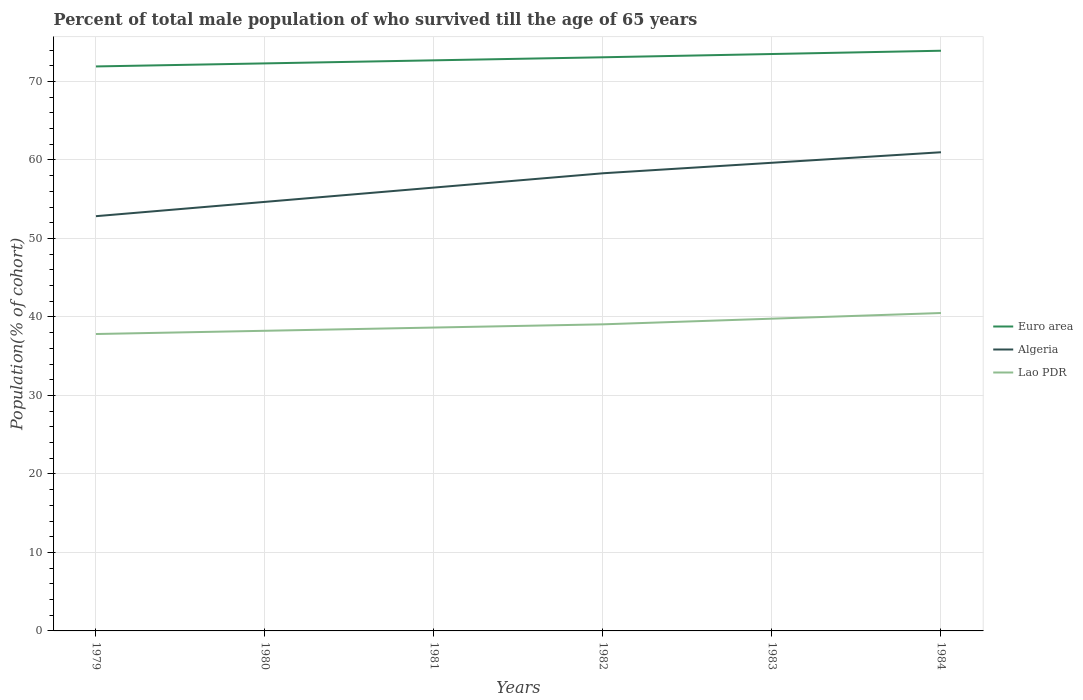Is the number of lines equal to the number of legend labels?
Provide a short and direct response. Yes. Across all years, what is the maximum percentage of total male population who survived till the age of 65 years in Euro area?
Your answer should be compact. 71.92. In which year was the percentage of total male population who survived till the age of 65 years in Euro area maximum?
Make the answer very short. 1979. What is the total percentage of total male population who survived till the age of 65 years in Lao PDR in the graph?
Offer a very short reply. -0.41. What is the difference between the highest and the second highest percentage of total male population who survived till the age of 65 years in Euro area?
Offer a terse response. 2. What is the difference between the highest and the lowest percentage of total male population who survived till the age of 65 years in Euro area?
Give a very brief answer. 3. Is the percentage of total male population who survived till the age of 65 years in Lao PDR strictly greater than the percentage of total male population who survived till the age of 65 years in Euro area over the years?
Your response must be concise. Yes. What is the difference between two consecutive major ticks on the Y-axis?
Ensure brevity in your answer.  10. Are the values on the major ticks of Y-axis written in scientific E-notation?
Make the answer very short. No. Does the graph contain grids?
Ensure brevity in your answer.  Yes. Where does the legend appear in the graph?
Make the answer very short. Center right. How are the legend labels stacked?
Ensure brevity in your answer.  Vertical. What is the title of the graph?
Provide a short and direct response. Percent of total male population of who survived till the age of 65 years. What is the label or title of the Y-axis?
Provide a succinct answer. Population(% of cohort). What is the Population(% of cohort) of Euro area in 1979?
Offer a very short reply. 71.92. What is the Population(% of cohort) in Algeria in 1979?
Make the answer very short. 52.84. What is the Population(% of cohort) in Lao PDR in 1979?
Provide a succinct answer. 37.83. What is the Population(% of cohort) of Euro area in 1980?
Your answer should be very brief. 72.31. What is the Population(% of cohort) of Algeria in 1980?
Offer a very short reply. 54.66. What is the Population(% of cohort) of Lao PDR in 1980?
Your answer should be very brief. 38.24. What is the Population(% of cohort) in Euro area in 1981?
Give a very brief answer. 72.7. What is the Population(% of cohort) of Algeria in 1981?
Provide a succinct answer. 56.49. What is the Population(% of cohort) of Lao PDR in 1981?
Provide a succinct answer. 38.65. What is the Population(% of cohort) in Euro area in 1982?
Provide a succinct answer. 73.09. What is the Population(% of cohort) in Algeria in 1982?
Make the answer very short. 58.31. What is the Population(% of cohort) of Lao PDR in 1982?
Give a very brief answer. 39.06. What is the Population(% of cohort) in Euro area in 1983?
Your answer should be compact. 73.5. What is the Population(% of cohort) in Algeria in 1983?
Offer a terse response. 59.65. What is the Population(% of cohort) of Lao PDR in 1983?
Make the answer very short. 39.78. What is the Population(% of cohort) of Euro area in 1984?
Give a very brief answer. 73.92. What is the Population(% of cohort) in Algeria in 1984?
Your answer should be compact. 60.99. What is the Population(% of cohort) of Lao PDR in 1984?
Keep it short and to the point. 40.5. Across all years, what is the maximum Population(% of cohort) in Euro area?
Your answer should be very brief. 73.92. Across all years, what is the maximum Population(% of cohort) of Algeria?
Provide a succinct answer. 60.99. Across all years, what is the maximum Population(% of cohort) in Lao PDR?
Provide a succinct answer. 40.5. Across all years, what is the minimum Population(% of cohort) in Euro area?
Offer a very short reply. 71.92. Across all years, what is the minimum Population(% of cohort) in Algeria?
Offer a very short reply. 52.84. Across all years, what is the minimum Population(% of cohort) in Lao PDR?
Provide a succinct answer. 37.83. What is the total Population(% of cohort) in Euro area in the graph?
Give a very brief answer. 437.43. What is the total Population(% of cohort) in Algeria in the graph?
Offer a very short reply. 342.93. What is the total Population(% of cohort) of Lao PDR in the graph?
Your answer should be compact. 234.07. What is the difference between the Population(% of cohort) of Euro area in 1979 and that in 1980?
Keep it short and to the point. -0.39. What is the difference between the Population(% of cohort) of Algeria in 1979 and that in 1980?
Keep it short and to the point. -1.82. What is the difference between the Population(% of cohort) of Lao PDR in 1979 and that in 1980?
Your response must be concise. -0.41. What is the difference between the Population(% of cohort) of Euro area in 1979 and that in 1981?
Make the answer very short. -0.78. What is the difference between the Population(% of cohort) of Algeria in 1979 and that in 1981?
Your response must be concise. -3.64. What is the difference between the Population(% of cohort) of Lao PDR in 1979 and that in 1981?
Ensure brevity in your answer.  -0.82. What is the difference between the Population(% of cohort) in Euro area in 1979 and that in 1982?
Ensure brevity in your answer.  -1.17. What is the difference between the Population(% of cohort) in Algeria in 1979 and that in 1982?
Make the answer very short. -5.47. What is the difference between the Population(% of cohort) in Lao PDR in 1979 and that in 1982?
Give a very brief answer. -1.23. What is the difference between the Population(% of cohort) in Euro area in 1979 and that in 1983?
Keep it short and to the point. -1.58. What is the difference between the Population(% of cohort) in Algeria in 1979 and that in 1983?
Keep it short and to the point. -6.81. What is the difference between the Population(% of cohort) of Lao PDR in 1979 and that in 1983?
Keep it short and to the point. -1.95. What is the difference between the Population(% of cohort) in Euro area in 1979 and that in 1984?
Give a very brief answer. -2. What is the difference between the Population(% of cohort) of Algeria in 1979 and that in 1984?
Give a very brief answer. -8.14. What is the difference between the Population(% of cohort) of Lao PDR in 1979 and that in 1984?
Offer a very short reply. -2.68. What is the difference between the Population(% of cohort) in Euro area in 1980 and that in 1981?
Keep it short and to the point. -0.39. What is the difference between the Population(% of cohort) of Algeria in 1980 and that in 1981?
Provide a short and direct response. -1.82. What is the difference between the Population(% of cohort) of Lao PDR in 1980 and that in 1981?
Make the answer very short. -0.41. What is the difference between the Population(% of cohort) of Euro area in 1980 and that in 1982?
Keep it short and to the point. -0.78. What is the difference between the Population(% of cohort) of Algeria in 1980 and that in 1982?
Offer a terse response. -3.64. What is the difference between the Population(% of cohort) in Lao PDR in 1980 and that in 1982?
Make the answer very short. -0.82. What is the difference between the Population(% of cohort) of Euro area in 1980 and that in 1983?
Provide a succinct answer. -1.19. What is the difference between the Population(% of cohort) in Algeria in 1980 and that in 1983?
Provide a short and direct response. -4.98. What is the difference between the Population(% of cohort) in Lao PDR in 1980 and that in 1983?
Make the answer very short. -1.54. What is the difference between the Population(% of cohort) of Euro area in 1980 and that in 1984?
Offer a terse response. -1.61. What is the difference between the Population(% of cohort) in Algeria in 1980 and that in 1984?
Your answer should be compact. -6.32. What is the difference between the Population(% of cohort) of Lao PDR in 1980 and that in 1984?
Offer a very short reply. -2.26. What is the difference between the Population(% of cohort) in Euro area in 1981 and that in 1982?
Offer a terse response. -0.39. What is the difference between the Population(% of cohort) in Algeria in 1981 and that in 1982?
Your answer should be compact. -1.82. What is the difference between the Population(% of cohort) of Lao PDR in 1981 and that in 1982?
Make the answer very short. -0.41. What is the difference between the Population(% of cohort) of Euro area in 1981 and that in 1983?
Ensure brevity in your answer.  -0.81. What is the difference between the Population(% of cohort) in Algeria in 1981 and that in 1983?
Keep it short and to the point. -3.16. What is the difference between the Population(% of cohort) in Lao PDR in 1981 and that in 1983?
Provide a succinct answer. -1.13. What is the difference between the Population(% of cohort) of Euro area in 1981 and that in 1984?
Make the answer very short. -1.22. What is the difference between the Population(% of cohort) of Lao PDR in 1981 and that in 1984?
Keep it short and to the point. -1.85. What is the difference between the Population(% of cohort) of Euro area in 1982 and that in 1983?
Provide a short and direct response. -0.42. What is the difference between the Population(% of cohort) of Algeria in 1982 and that in 1983?
Keep it short and to the point. -1.34. What is the difference between the Population(% of cohort) in Lao PDR in 1982 and that in 1983?
Your response must be concise. -0.72. What is the difference between the Population(% of cohort) in Euro area in 1982 and that in 1984?
Give a very brief answer. -0.83. What is the difference between the Population(% of cohort) in Algeria in 1982 and that in 1984?
Ensure brevity in your answer.  -2.68. What is the difference between the Population(% of cohort) in Lao PDR in 1982 and that in 1984?
Give a very brief answer. -1.44. What is the difference between the Population(% of cohort) of Euro area in 1983 and that in 1984?
Keep it short and to the point. -0.42. What is the difference between the Population(% of cohort) in Algeria in 1983 and that in 1984?
Offer a very short reply. -1.34. What is the difference between the Population(% of cohort) of Lao PDR in 1983 and that in 1984?
Ensure brevity in your answer.  -0.72. What is the difference between the Population(% of cohort) of Euro area in 1979 and the Population(% of cohort) of Algeria in 1980?
Offer a terse response. 17.26. What is the difference between the Population(% of cohort) in Euro area in 1979 and the Population(% of cohort) in Lao PDR in 1980?
Keep it short and to the point. 33.68. What is the difference between the Population(% of cohort) of Algeria in 1979 and the Population(% of cohort) of Lao PDR in 1980?
Ensure brevity in your answer.  14.6. What is the difference between the Population(% of cohort) in Euro area in 1979 and the Population(% of cohort) in Algeria in 1981?
Provide a short and direct response. 15.43. What is the difference between the Population(% of cohort) in Euro area in 1979 and the Population(% of cohort) in Lao PDR in 1981?
Make the answer very short. 33.27. What is the difference between the Population(% of cohort) in Algeria in 1979 and the Population(% of cohort) in Lao PDR in 1981?
Ensure brevity in your answer.  14.19. What is the difference between the Population(% of cohort) in Euro area in 1979 and the Population(% of cohort) in Algeria in 1982?
Provide a short and direct response. 13.61. What is the difference between the Population(% of cohort) in Euro area in 1979 and the Population(% of cohort) in Lao PDR in 1982?
Provide a short and direct response. 32.86. What is the difference between the Population(% of cohort) in Algeria in 1979 and the Population(% of cohort) in Lao PDR in 1982?
Offer a terse response. 13.78. What is the difference between the Population(% of cohort) of Euro area in 1979 and the Population(% of cohort) of Algeria in 1983?
Your answer should be compact. 12.27. What is the difference between the Population(% of cohort) of Euro area in 1979 and the Population(% of cohort) of Lao PDR in 1983?
Provide a succinct answer. 32.14. What is the difference between the Population(% of cohort) in Algeria in 1979 and the Population(% of cohort) in Lao PDR in 1983?
Your answer should be very brief. 13.06. What is the difference between the Population(% of cohort) in Euro area in 1979 and the Population(% of cohort) in Algeria in 1984?
Keep it short and to the point. 10.93. What is the difference between the Population(% of cohort) of Euro area in 1979 and the Population(% of cohort) of Lao PDR in 1984?
Offer a very short reply. 31.41. What is the difference between the Population(% of cohort) in Algeria in 1979 and the Population(% of cohort) in Lao PDR in 1984?
Make the answer very short. 12.34. What is the difference between the Population(% of cohort) of Euro area in 1980 and the Population(% of cohort) of Algeria in 1981?
Provide a succinct answer. 15.82. What is the difference between the Population(% of cohort) of Euro area in 1980 and the Population(% of cohort) of Lao PDR in 1981?
Offer a terse response. 33.66. What is the difference between the Population(% of cohort) in Algeria in 1980 and the Population(% of cohort) in Lao PDR in 1981?
Your answer should be very brief. 16.01. What is the difference between the Population(% of cohort) in Euro area in 1980 and the Population(% of cohort) in Algeria in 1982?
Give a very brief answer. 14. What is the difference between the Population(% of cohort) of Euro area in 1980 and the Population(% of cohort) of Lao PDR in 1982?
Your answer should be very brief. 33.25. What is the difference between the Population(% of cohort) of Algeria in 1980 and the Population(% of cohort) of Lao PDR in 1982?
Provide a short and direct response. 15.6. What is the difference between the Population(% of cohort) in Euro area in 1980 and the Population(% of cohort) in Algeria in 1983?
Offer a terse response. 12.66. What is the difference between the Population(% of cohort) of Euro area in 1980 and the Population(% of cohort) of Lao PDR in 1983?
Your answer should be compact. 32.52. What is the difference between the Population(% of cohort) in Algeria in 1980 and the Population(% of cohort) in Lao PDR in 1983?
Your answer should be very brief. 14.88. What is the difference between the Population(% of cohort) in Euro area in 1980 and the Population(% of cohort) in Algeria in 1984?
Give a very brief answer. 11.32. What is the difference between the Population(% of cohort) in Euro area in 1980 and the Population(% of cohort) in Lao PDR in 1984?
Provide a succinct answer. 31.8. What is the difference between the Population(% of cohort) of Algeria in 1980 and the Population(% of cohort) of Lao PDR in 1984?
Provide a succinct answer. 14.16. What is the difference between the Population(% of cohort) of Euro area in 1981 and the Population(% of cohort) of Algeria in 1982?
Offer a terse response. 14.39. What is the difference between the Population(% of cohort) of Euro area in 1981 and the Population(% of cohort) of Lao PDR in 1982?
Your answer should be compact. 33.63. What is the difference between the Population(% of cohort) in Algeria in 1981 and the Population(% of cohort) in Lao PDR in 1982?
Offer a terse response. 17.42. What is the difference between the Population(% of cohort) in Euro area in 1981 and the Population(% of cohort) in Algeria in 1983?
Provide a short and direct response. 13.05. What is the difference between the Population(% of cohort) in Euro area in 1981 and the Population(% of cohort) in Lao PDR in 1983?
Your response must be concise. 32.91. What is the difference between the Population(% of cohort) of Algeria in 1981 and the Population(% of cohort) of Lao PDR in 1983?
Your answer should be very brief. 16.7. What is the difference between the Population(% of cohort) in Euro area in 1981 and the Population(% of cohort) in Algeria in 1984?
Your answer should be very brief. 11.71. What is the difference between the Population(% of cohort) in Euro area in 1981 and the Population(% of cohort) in Lao PDR in 1984?
Make the answer very short. 32.19. What is the difference between the Population(% of cohort) of Algeria in 1981 and the Population(% of cohort) of Lao PDR in 1984?
Make the answer very short. 15.98. What is the difference between the Population(% of cohort) of Euro area in 1982 and the Population(% of cohort) of Algeria in 1983?
Provide a succinct answer. 13.44. What is the difference between the Population(% of cohort) of Euro area in 1982 and the Population(% of cohort) of Lao PDR in 1983?
Offer a very short reply. 33.3. What is the difference between the Population(% of cohort) of Algeria in 1982 and the Population(% of cohort) of Lao PDR in 1983?
Give a very brief answer. 18.52. What is the difference between the Population(% of cohort) of Euro area in 1982 and the Population(% of cohort) of Algeria in 1984?
Provide a succinct answer. 12.1. What is the difference between the Population(% of cohort) in Euro area in 1982 and the Population(% of cohort) in Lao PDR in 1984?
Provide a succinct answer. 32.58. What is the difference between the Population(% of cohort) in Algeria in 1982 and the Population(% of cohort) in Lao PDR in 1984?
Your response must be concise. 17.8. What is the difference between the Population(% of cohort) of Euro area in 1983 and the Population(% of cohort) of Algeria in 1984?
Give a very brief answer. 12.52. What is the difference between the Population(% of cohort) in Euro area in 1983 and the Population(% of cohort) in Lao PDR in 1984?
Ensure brevity in your answer.  33. What is the difference between the Population(% of cohort) of Algeria in 1983 and the Population(% of cohort) of Lao PDR in 1984?
Offer a terse response. 19.14. What is the average Population(% of cohort) in Euro area per year?
Provide a succinct answer. 72.91. What is the average Population(% of cohort) of Algeria per year?
Your answer should be compact. 57.16. What is the average Population(% of cohort) of Lao PDR per year?
Your response must be concise. 39.01. In the year 1979, what is the difference between the Population(% of cohort) in Euro area and Population(% of cohort) in Algeria?
Offer a terse response. 19.08. In the year 1979, what is the difference between the Population(% of cohort) in Euro area and Population(% of cohort) in Lao PDR?
Your answer should be very brief. 34.09. In the year 1979, what is the difference between the Population(% of cohort) in Algeria and Population(% of cohort) in Lao PDR?
Your response must be concise. 15.01. In the year 1980, what is the difference between the Population(% of cohort) of Euro area and Population(% of cohort) of Algeria?
Provide a succinct answer. 17.64. In the year 1980, what is the difference between the Population(% of cohort) of Euro area and Population(% of cohort) of Lao PDR?
Your answer should be compact. 34.07. In the year 1980, what is the difference between the Population(% of cohort) in Algeria and Population(% of cohort) in Lao PDR?
Keep it short and to the point. 16.42. In the year 1981, what is the difference between the Population(% of cohort) of Euro area and Population(% of cohort) of Algeria?
Your answer should be very brief. 16.21. In the year 1981, what is the difference between the Population(% of cohort) in Euro area and Population(% of cohort) in Lao PDR?
Your answer should be compact. 34.05. In the year 1981, what is the difference between the Population(% of cohort) in Algeria and Population(% of cohort) in Lao PDR?
Your response must be concise. 17.83. In the year 1982, what is the difference between the Population(% of cohort) of Euro area and Population(% of cohort) of Algeria?
Make the answer very short. 14.78. In the year 1982, what is the difference between the Population(% of cohort) of Euro area and Population(% of cohort) of Lao PDR?
Your answer should be very brief. 34.02. In the year 1982, what is the difference between the Population(% of cohort) in Algeria and Population(% of cohort) in Lao PDR?
Give a very brief answer. 19.25. In the year 1983, what is the difference between the Population(% of cohort) of Euro area and Population(% of cohort) of Algeria?
Provide a succinct answer. 13.86. In the year 1983, what is the difference between the Population(% of cohort) in Euro area and Population(% of cohort) in Lao PDR?
Ensure brevity in your answer.  33.72. In the year 1983, what is the difference between the Population(% of cohort) of Algeria and Population(% of cohort) of Lao PDR?
Keep it short and to the point. 19.86. In the year 1984, what is the difference between the Population(% of cohort) in Euro area and Population(% of cohort) in Algeria?
Offer a terse response. 12.93. In the year 1984, what is the difference between the Population(% of cohort) in Euro area and Population(% of cohort) in Lao PDR?
Make the answer very short. 33.42. In the year 1984, what is the difference between the Population(% of cohort) of Algeria and Population(% of cohort) of Lao PDR?
Provide a short and direct response. 20.48. What is the ratio of the Population(% of cohort) of Euro area in 1979 to that in 1980?
Make the answer very short. 0.99. What is the ratio of the Population(% of cohort) in Algeria in 1979 to that in 1980?
Ensure brevity in your answer.  0.97. What is the ratio of the Population(% of cohort) of Euro area in 1979 to that in 1981?
Provide a succinct answer. 0.99. What is the ratio of the Population(% of cohort) in Algeria in 1979 to that in 1981?
Make the answer very short. 0.94. What is the ratio of the Population(% of cohort) in Lao PDR in 1979 to that in 1981?
Ensure brevity in your answer.  0.98. What is the ratio of the Population(% of cohort) of Algeria in 1979 to that in 1982?
Make the answer very short. 0.91. What is the ratio of the Population(% of cohort) of Lao PDR in 1979 to that in 1982?
Your response must be concise. 0.97. What is the ratio of the Population(% of cohort) in Euro area in 1979 to that in 1983?
Provide a succinct answer. 0.98. What is the ratio of the Population(% of cohort) of Algeria in 1979 to that in 1983?
Your answer should be very brief. 0.89. What is the ratio of the Population(% of cohort) of Lao PDR in 1979 to that in 1983?
Offer a terse response. 0.95. What is the ratio of the Population(% of cohort) in Euro area in 1979 to that in 1984?
Give a very brief answer. 0.97. What is the ratio of the Population(% of cohort) in Algeria in 1979 to that in 1984?
Offer a terse response. 0.87. What is the ratio of the Population(% of cohort) of Lao PDR in 1979 to that in 1984?
Give a very brief answer. 0.93. What is the ratio of the Population(% of cohort) in Lao PDR in 1980 to that in 1981?
Your response must be concise. 0.99. What is the ratio of the Population(% of cohort) of Euro area in 1980 to that in 1982?
Ensure brevity in your answer.  0.99. What is the ratio of the Population(% of cohort) of Lao PDR in 1980 to that in 1982?
Give a very brief answer. 0.98. What is the ratio of the Population(% of cohort) in Euro area in 1980 to that in 1983?
Provide a succinct answer. 0.98. What is the ratio of the Population(% of cohort) of Algeria in 1980 to that in 1983?
Provide a short and direct response. 0.92. What is the ratio of the Population(% of cohort) of Lao PDR in 1980 to that in 1983?
Make the answer very short. 0.96. What is the ratio of the Population(% of cohort) in Euro area in 1980 to that in 1984?
Ensure brevity in your answer.  0.98. What is the ratio of the Population(% of cohort) of Algeria in 1980 to that in 1984?
Offer a terse response. 0.9. What is the ratio of the Population(% of cohort) in Lao PDR in 1980 to that in 1984?
Your response must be concise. 0.94. What is the ratio of the Population(% of cohort) of Euro area in 1981 to that in 1982?
Give a very brief answer. 0.99. What is the ratio of the Population(% of cohort) of Algeria in 1981 to that in 1982?
Give a very brief answer. 0.97. What is the ratio of the Population(% of cohort) of Algeria in 1981 to that in 1983?
Ensure brevity in your answer.  0.95. What is the ratio of the Population(% of cohort) in Lao PDR in 1981 to that in 1983?
Your answer should be very brief. 0.97. What is the ratio of the Population(% of cohort) in Euro area in 1981 to that in 1984?
Provide a succinct answer. 0.98. What is the ratio of the Population(% of cohort) in Algeria in 1981 to that in 1984?
Make the answer very short. 0.93. What is the ratio of the Population(% of cohort) of Lao PDR in 1981 to that in 1984?
Your answer should be very brief. 0.95. What is the ratio of the Population(% of cohort) of Algeria in 1982 to that in 1983?
Your response must be concise. 0.98. What is the ratio of the Population(% of cohort) in Lao PDR in 1982 to that in 1983?
Your answer should be compact. 0.98. What is the ratio of the Population(% of cohort) in Euro area in 1982 to that in 1984?
Offer a very short reply. 0.99. What is the ratio of the Population(% of cohort) of Algeria in 1982 to that in 1984?
Offer a very short reply. 0.96. What is the ratio of the Population(% of cohort) of Lao PDR in 1982 to that in 1984?
Your response must be concise. 0.96. What is the ratio of the Population(% of cohort) of Lao PDR in 1983 to that in 1984?
Your answer should be compact. 0.98. What is the difference between the highest and the second highest Population(% of cohort) in Euro area?
Provide a short and direct response. 0.42. What is the difference between the highest and the second highest Population(% of cohort) in Algeria?
Your response must be concise. 1.34. What is the difference between the highest and the second highest Population(% of cohort) of Lao PDR?
Give a very brief answer. 0.72. What is the difference between the highest and the lowest Population(% of cohort) in Euro area?
Make the answer very short. 2. What is the difference between the highest and the lowest Population(% of cohort) of Algeria?
Ensure brevity in your answer.  8.14. What is the difference between the highest and the lowest Population(% of cohort) of Lao PDR?
Offer a very short reply. 2.68. 